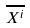Convert formula to latex. <formula><loc_0><loc_0><loc_500><loc_500>\overline { X ^ { i } }</formula> 